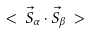Convert formula to latex. <formula><loc_0><loc_0><loc_500><loc_500>< \, \vec { S } _ { \alpha } \cdot \vec { S } _ { \beta } \, ></formula> 